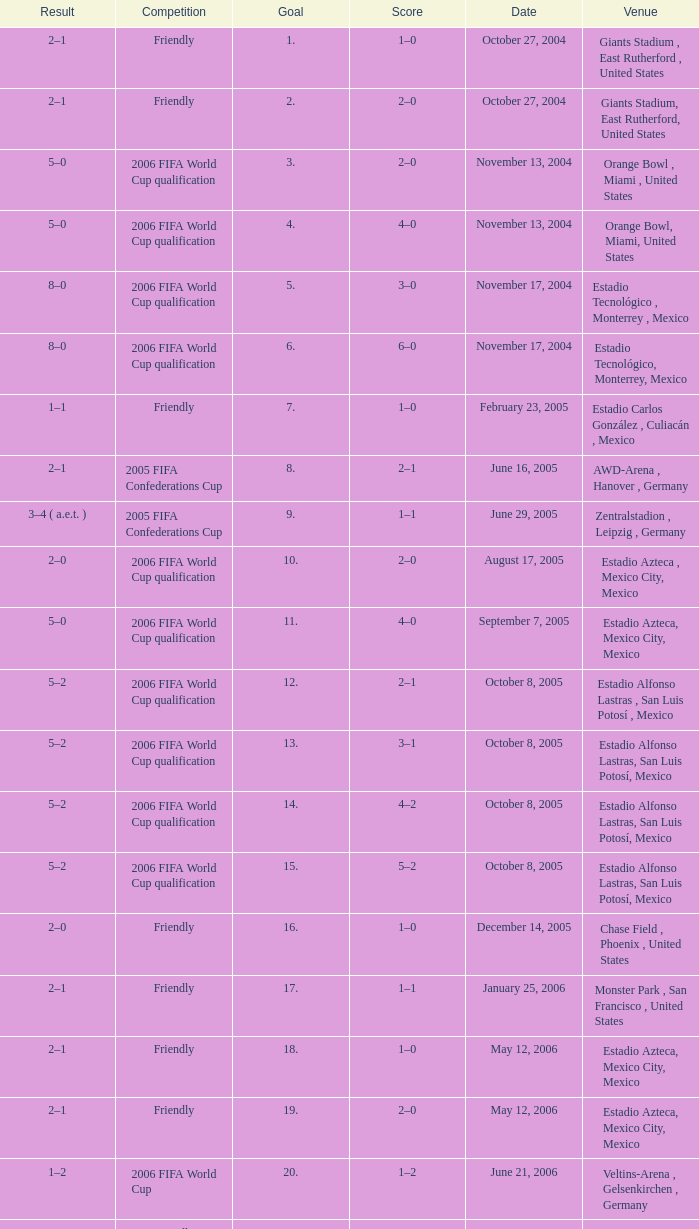Which Score has a Result of 2–1, and a Competition of friendly, and a Goal smaller than 17? 1–0, 2–0. 